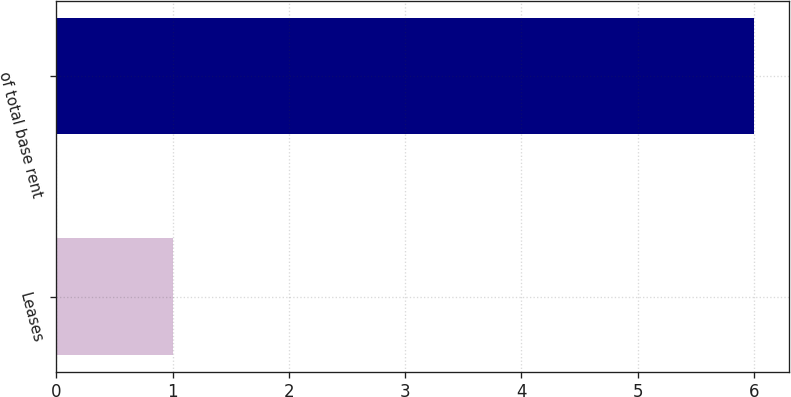Convert chart. <chart><loc_0><loc_0><loc_500><loc_500><bar_chart><fcel>Leases<fcel>of total base rent<nl><fcel>1<fcel>6<nl></chart> 